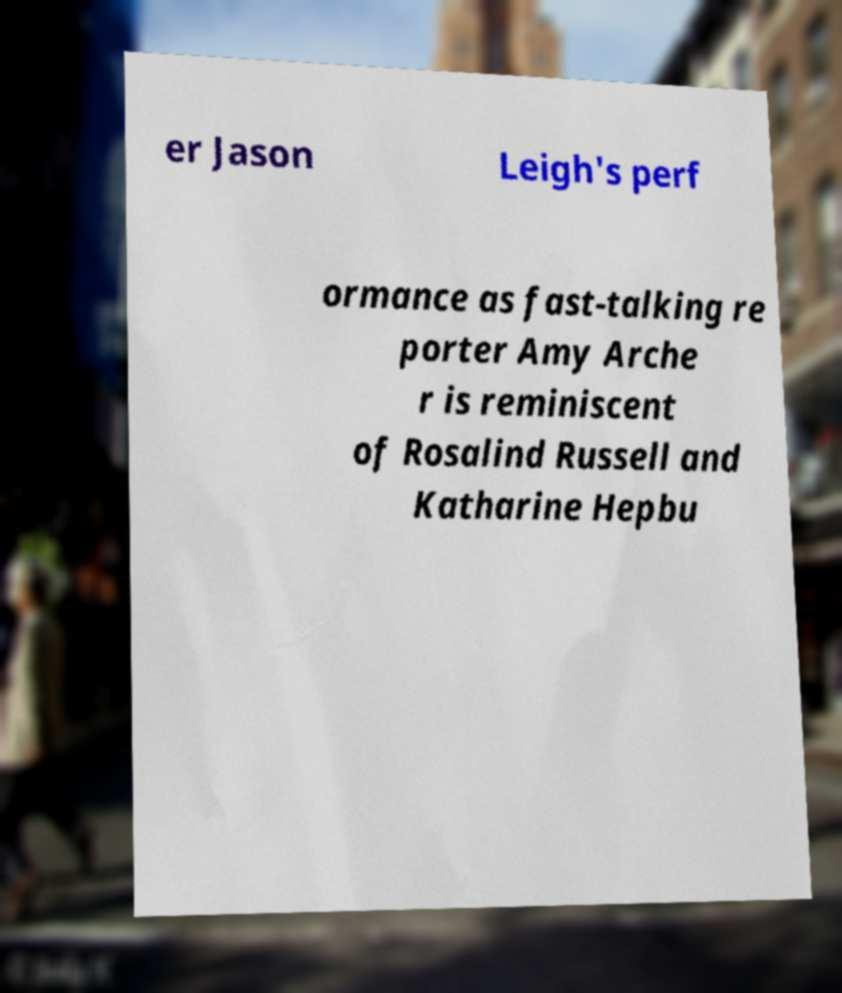Could you extract and type out the text from this image? er Jason Leigh's perf ormance as fast-talking re porter Amy Arche r is reminiscent of Rosalind Russell and Katharine Hepbu 